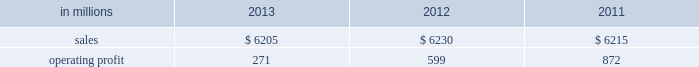Million excluding a gain on a bargain purchase price adjustment on the acquisition of a majority share of our operations in turkey and restructuring costs ) compared with $ 53 million ( $ 72 million excluding restructuring costs ) in 2012 and $ 66 million ( $ 61 million excluding a gain for a bargain purchase price adjustment on an acquisition by our then joint venture in turkey and costs associated with the closure of our etienne mill in france in 2009 ) in 2011 .
Sales volumes in 2013 were higher than in 2012 reflecting strong demand for packaging in the agricultural markets in morocco and turkey .
In europe , sales volumes decreased slightly due to continuing weak demand for packaging in the industrial markets , and lower demand for packaging in the agricultural markets resulting from poor weather conditions .
Average sales margins were significantly lower due to input costs for containerboard rising ahead of box sales price increases .
Other input costs were also higher , primarily for energy .
Operating profits in 2013 and 2012 included net gains of $ 13 million and $ 10 million , respectively , for insurance settlements and italian government grants , partially offset by additional operating costs , related to the earthquakes in northern italy in may 2012 which affected our san felice box plant .
Entering the first quarter of 2014 , sales volumes are expected to increase slightly reflecting higher demand for packaging in the industrial markets .
Average sales margins are expected to gradually improve as a result of slight reductions in material costs and planned box price increases .
Other input costs should be about flat .
Brazilian industrial packaging includes the results of orsa international paper embalagens s.a. , a corrugated packaging producer in which international paper acquired a 75% ( 75 % ) share in january 2013 .
Net sales were $ 335 million in 2013 .
Operating profits in 2013 were a loss of $ 2 million ( a gain of $ 2 million excluding acquisition and integration costs ) .
Looking ahead to the first quarter of 2014 , sales volumes are expected to be seasonally lower than in the fourth quarter of 2013 .
Average sales margins should improve reflecting the partial implementation of an announced sales price increase and a more favorable product mix .
Operating costs and input costs are expected to be lower .
Asian industrial packaging net sales were $ 400 million in 2013 compared with $ 400 million in 2012 and $ 410 million in 2011 .
Operating profits for the packaging operations were a loss of $ 5 million in 2013 ( a loss of $ 1 million excluding restructuring costs ) compared with gains of $ 2 million in 2012 and $ 2 million in 2011 .
Operating profits were favorably impacted in 2013 by higher average sales margins and slightly higher sales volumes compared with 2012 , but these benefits were offset by higher operating costs .
Looking ahead to the first quarter of 2014 , sales volumes and average sales margins are expected to be seasonally soft .
Net sales for the distribution operations were $ 285 million in 2013 compared with $ 260 million in 2012 and $ 285 million in 2011 .
Operating profits were $ 3 million in 2013 , 2012 and 2011 .
Printing papers demand for printing papers products is closely correlated with changes in commercial printing and advertising activity , direct mail volumes and , for uncoated cut-size products , with changes in white- collar employment levels that affect the usage of copy and laser printer paper .
Pulp is further affected by changes in currency rates that can enhance or disadvantage producers in different geographic regions .
Principal cost drivers include manufacturing efficiency , raw material and energy costs and freight costs .
Printing papers net sales for 2013 were about flat with both 2012 and 2011 .
Operating profits in 2013 were 55% ( 55 % ) lower than in 2012 and 69% ( 69 % ) lower than in 2011 .
Excluding facility closure costs and impairment costs , operating profits in 2013 were 15% ( 15 % ) lower than in 2012 and 40% ( 40 % ) lower than in 2011 .
Benefits from lower operating costs ( $ 81 million ) and lower maintenance outage costs ( $ 17 million ) were more than offset by lower average sales price realizations ( $ 38 million ) , lower sales volumes ( $ 14 million ) , higher input costs ( $ 99 million ) and higher other costs ( $ 34 million ) .
In addition , operating profits in 2013 included costs of $ 118 million associated with the announced closure of our courtland , alabama mill .
During 2013 , the company accelerated depreciation for certain courtland assets , and diligently evaluated certain other assets for possible alternative uses by one of our other businesses .
The net book value of these assets at december 31 , 2013 was approximately $ 470 million .
During 2014 , we have continued our evaluation and expect to conclude as to any uses for these assets during the first quarter of 2014 .
Operating profits also included a $ 123 million impairment charge associated with goodwill and a trade name intangible asset in our india papers business .
Operating profits in 2011 included a $ 24 million gain related to the announced repurposing of our franklin , virginia mill to produce fluff pulp and an $ 11 million impairment charge related to our inverurie , scotland mill that was closed in 2009 .
Printing papers .
North american printing papers net sales were $ 2.6 billion in 2013 , $ 2.7 billion in 2012 and $ 2.8 billion in 2011. .
In 2012 what percentage of printing papers sales where attributable to north american printing papers net sales? 
Computations: ((2.7 * 1000) / 6230)
Answer: 0.43339. 